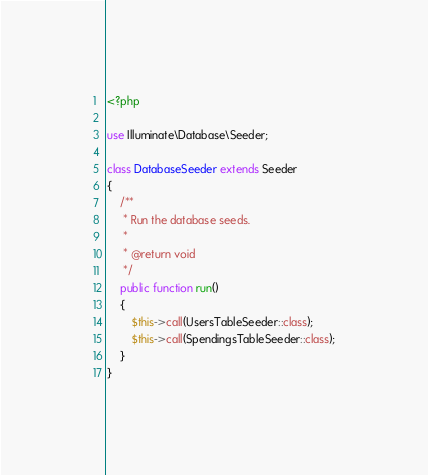Convert code to text. <code><loc_0><loc_0><loc_500><loc_500><_PHP_><?php

use Illuminate\Database\Seeder;

class DatabaseSeeder extends Seeder
{
    /**
     * Run the database seeds.
     *
     * @return void
     */
    public function run()
    {
        $this->call(UsersTableSeeder::class);
        $this->call(SpendingsTableSeeder::class);
    }
}
</code> 